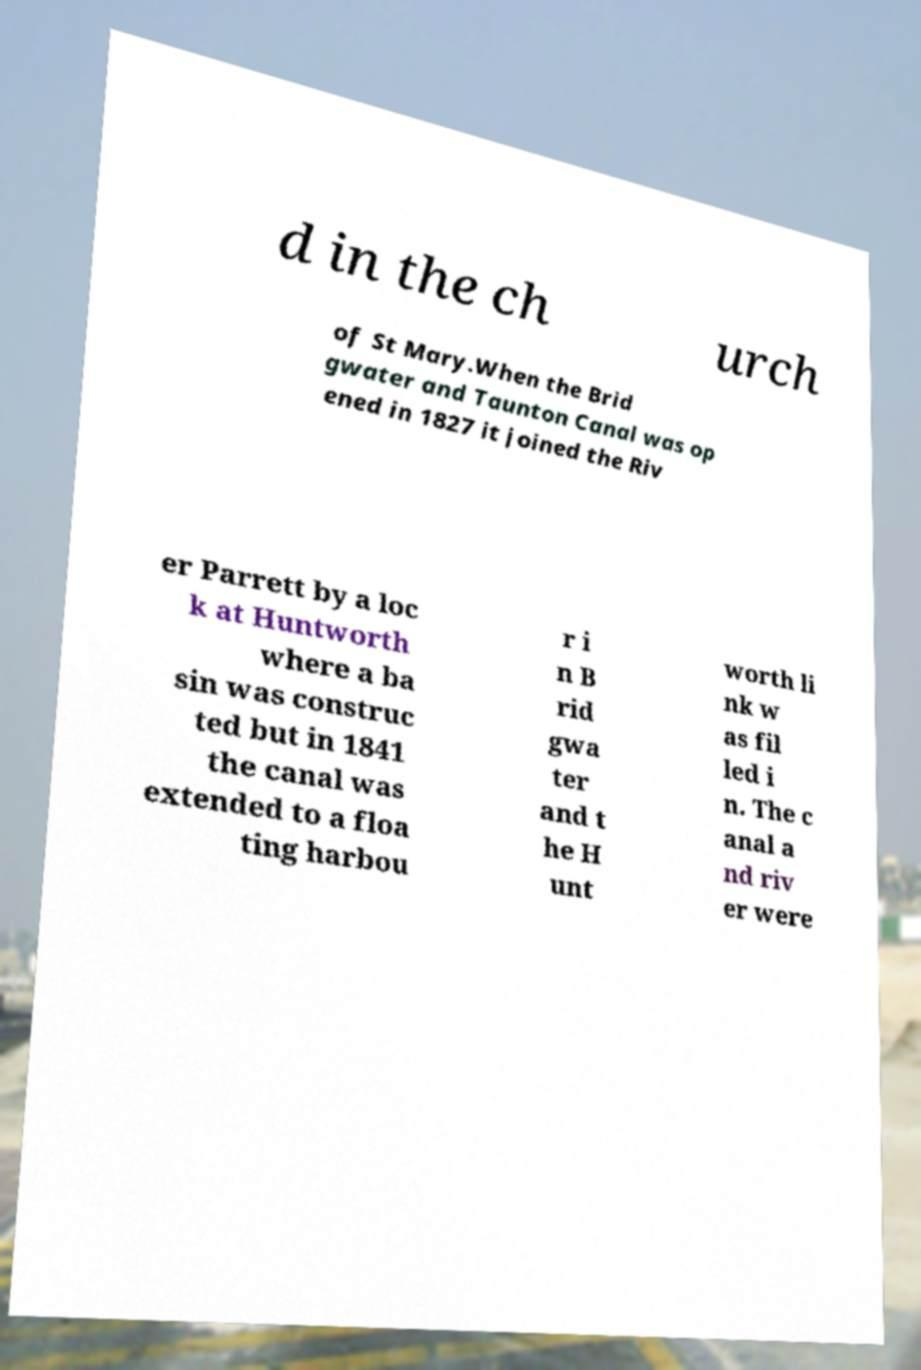I need the written content from this picture converted into text. Can you do that? d in the ch urch of St Mary.When the Brid gwater and Taunton Canal was op ened in 1827 it joined the Riv er Parrett by a loc k at Huntworth where a ba sin was construc ted but in 1841 the canal was extended to a floa ting harbou r i n B rid gwa ter and t he H unt worth li nk w as fil led i n. The c anal a nd riv er were 